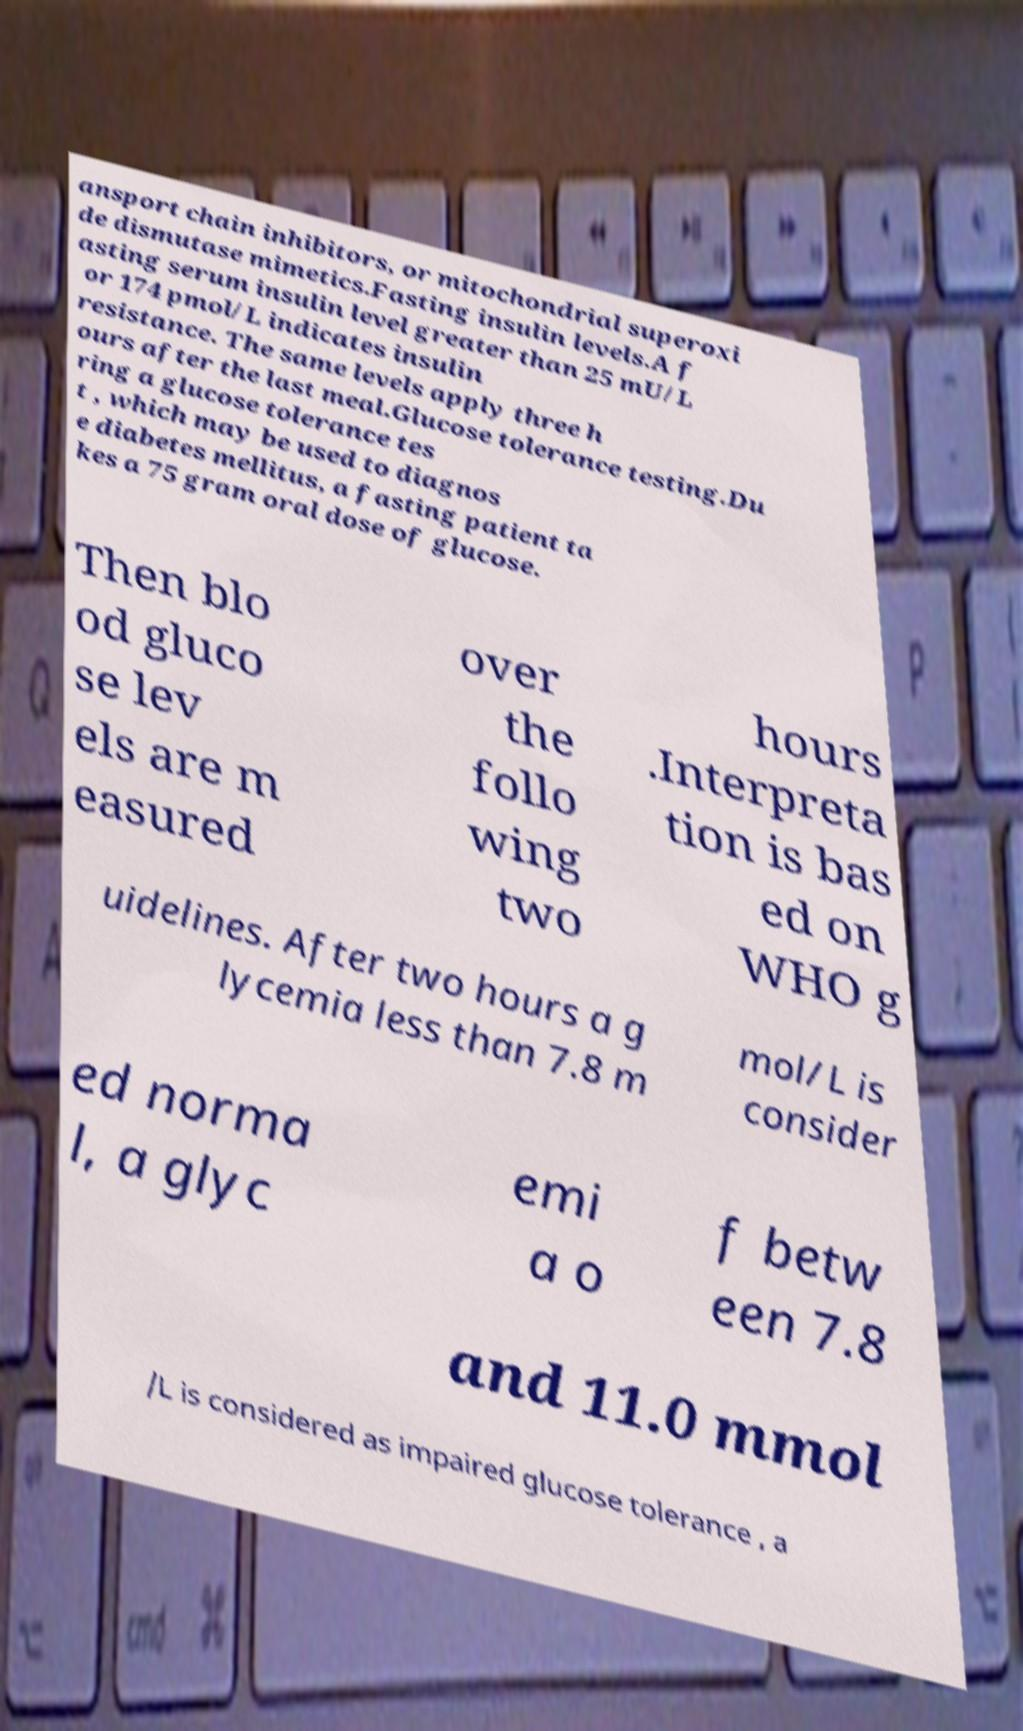For documentation purposes, I need the text within this image transcribed. Could you provide that? ansport chain inhibitors, or mitochondrial superoxi de dismutase mimetics.Fasting insulin levels.A f asting serum insulin level greater than 25 mU/L or 174 pmol/L indicates insulin resistance. The same levels apply three h ours after the last meal.Glucose tolerance testing.Du ring a glucose tolerance tes t , which may be used to diagnos e diabetes mellitus, a fasting patient ta kes a 75 gram oral dose of glucose. Then blo od gluco se lev els are m easured over the follo wing two hours .Interpreta tion is bas ed on WHO g uidelines. After two hours a g lycemia less than 7.8 m mol/L is consider ed norma l, a glyc emi a o f betw een 7.8 and 11.0 mmol /L is considered as impaired glucose tolerance , a 